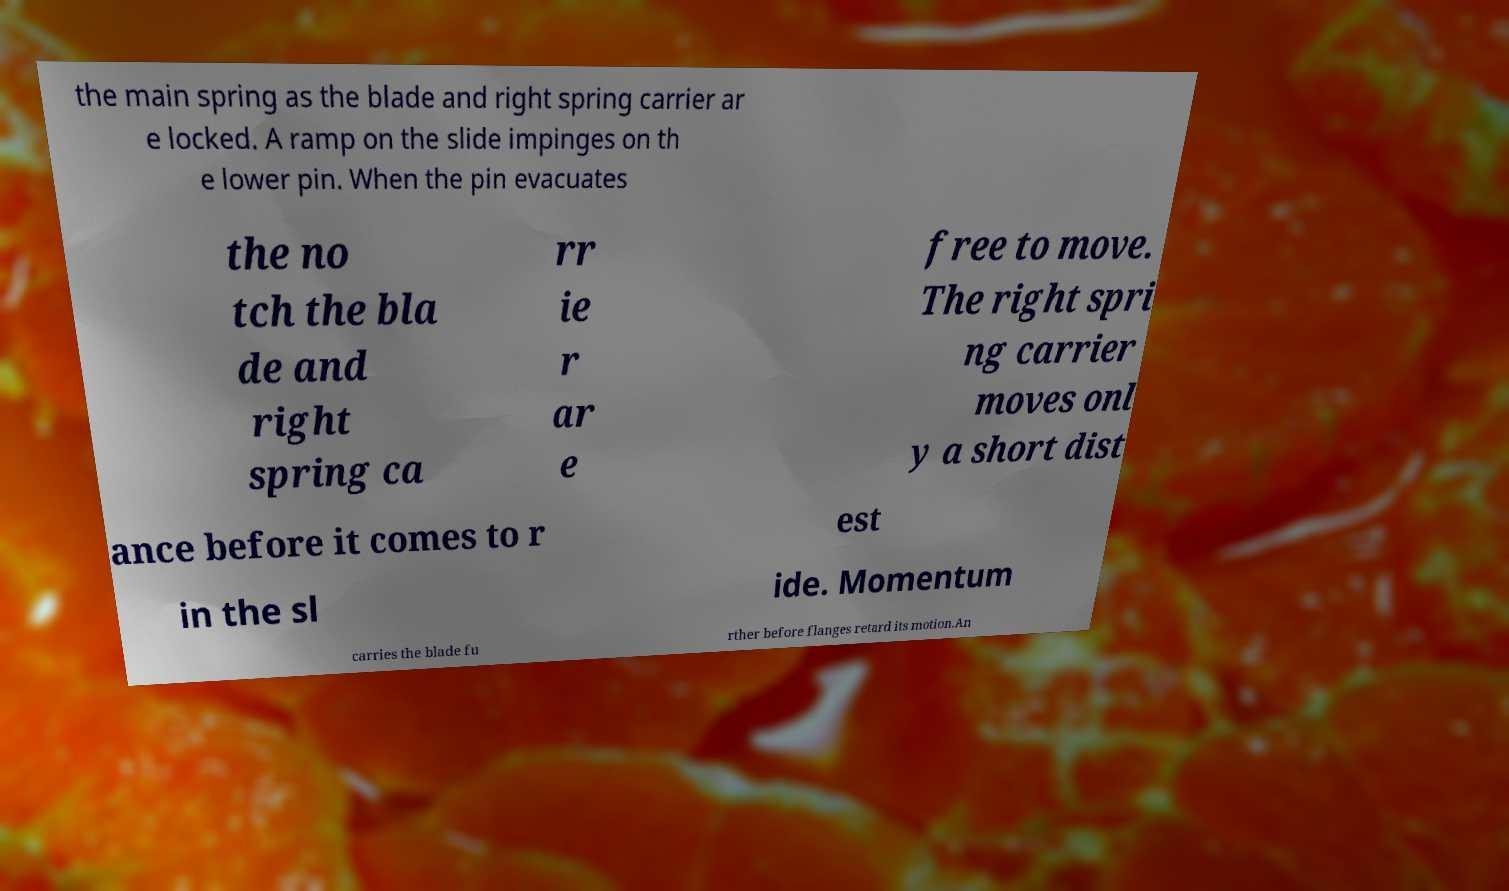For documentation purposes, I need the text within this image transcribed. Could you provide that? the main spring as the blade and right spring carrier ar e locked. A ramp on the slide impinges on th e lower pin. When the pin evacuates the no tch the bla de and right spring ca rr ie r ar e free to move. The right spri ng carrier moves onl y a short dist ance before it comes to r est in the sl ide. Momentum carries the blade fu rther before flanges retard its motion.An 